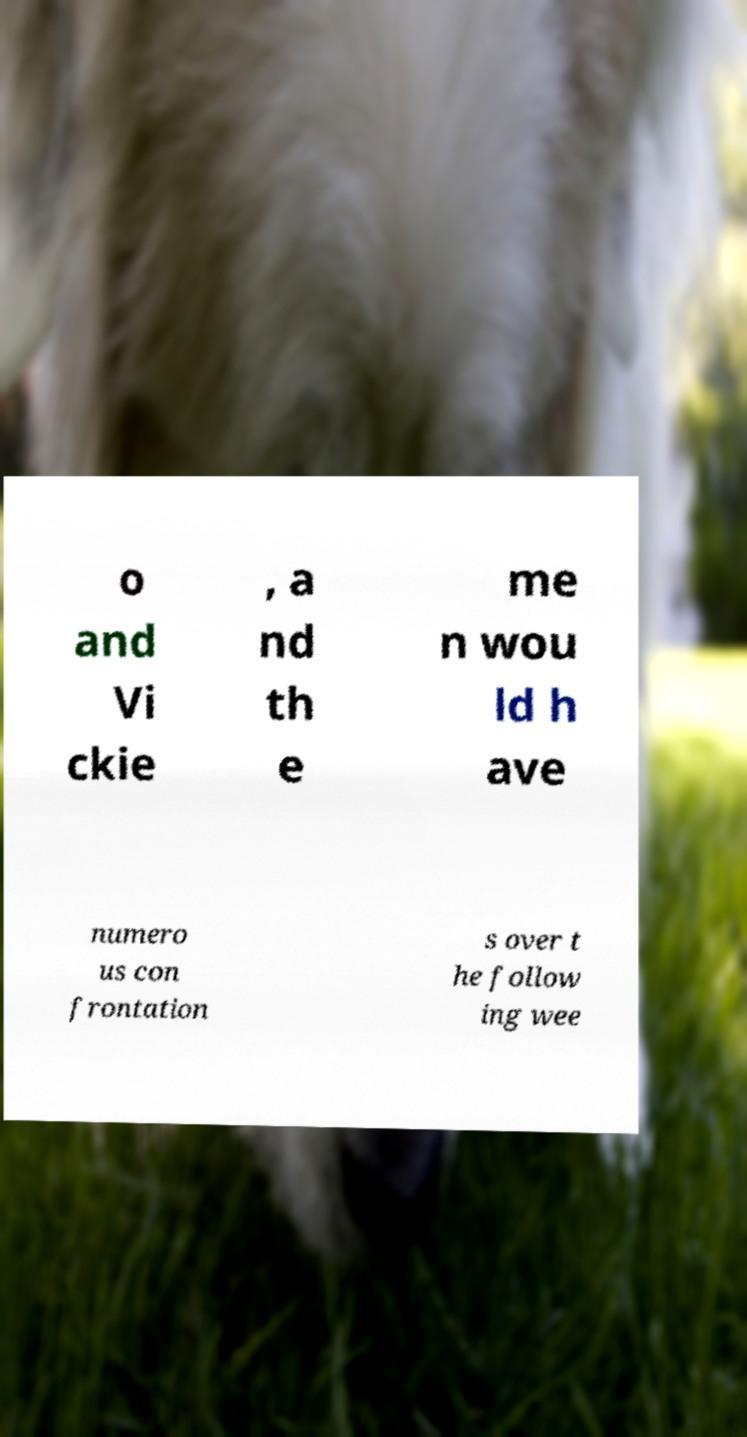What messages or text are displayed in this image? I need them in a readable, typed format. o and Vi ckie , a nd th e me n wou ld h ave numero us con frontation s over t he follow ing wee 